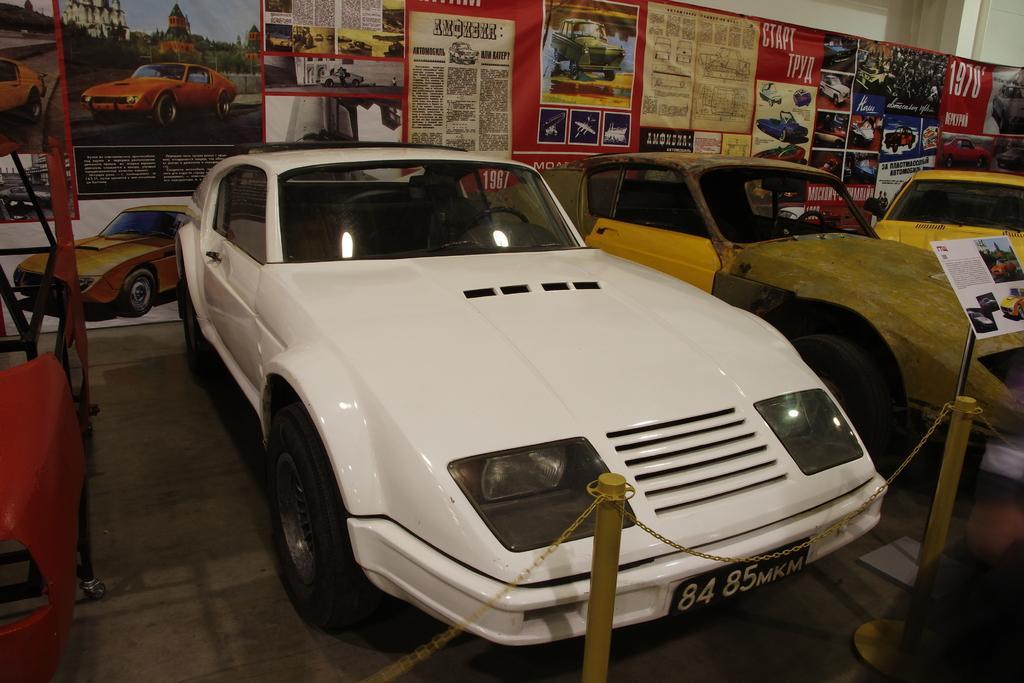Please provide a concise description of this image. In this image we can see motor vehicles on the floor, iron poles, chain and advertisements in the background. 